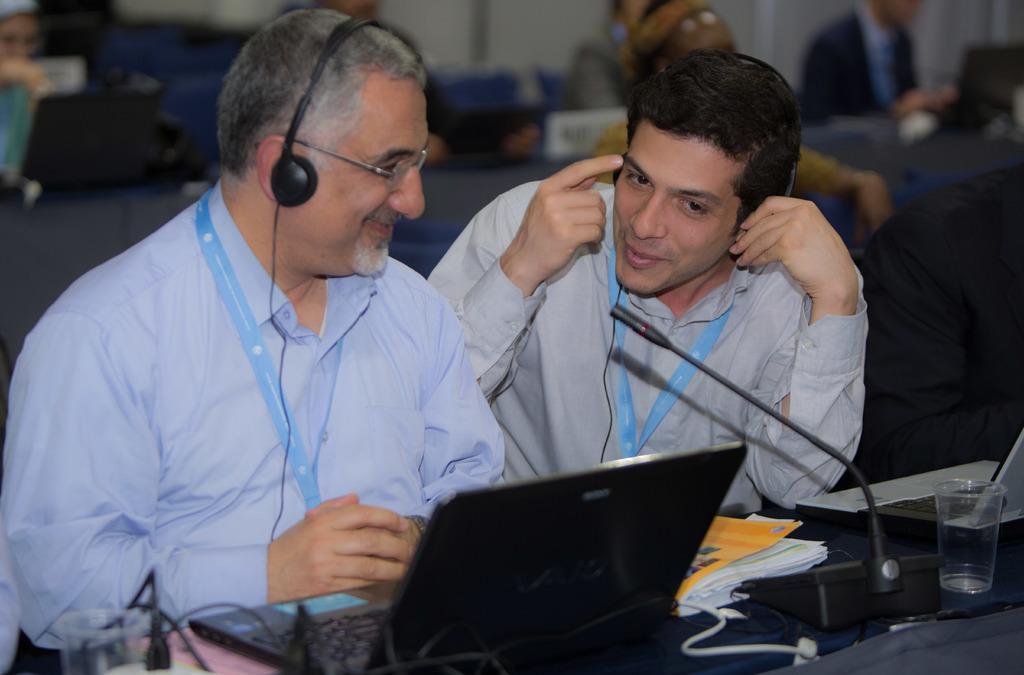Describe this image in one or two sentences. There are two men sitting and smiling and wired headsets,in front of these two men we can see laptops,microphone,cables and papers on the table. Background we can see wall and people. 